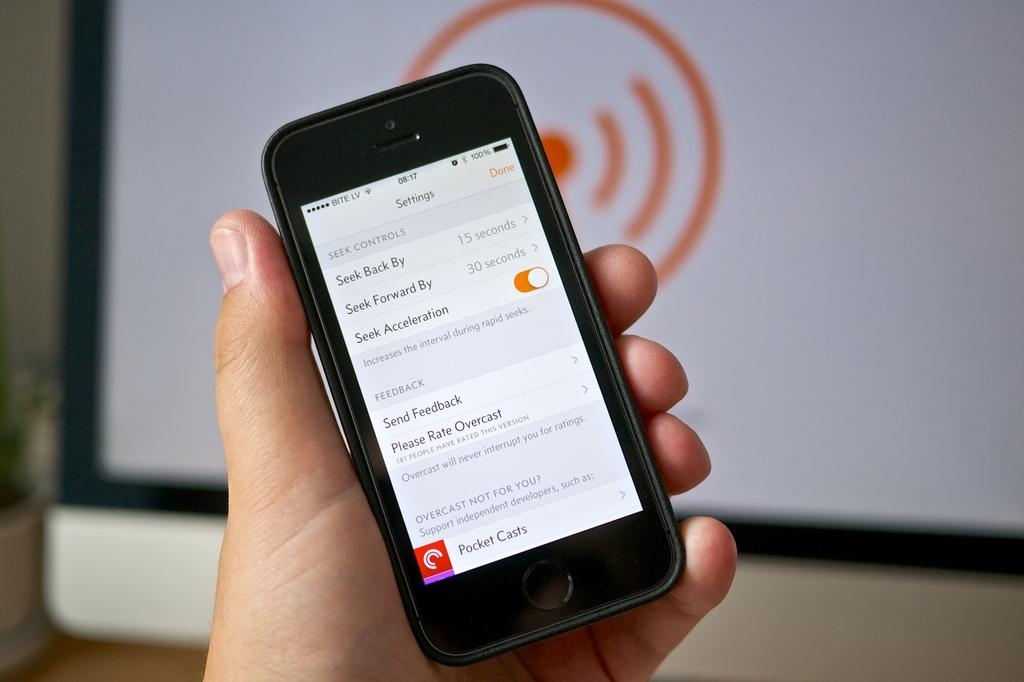<image>
Render a clear and concise summary of the photo. A hand holds a smartphone that is opened up to the settings page. 